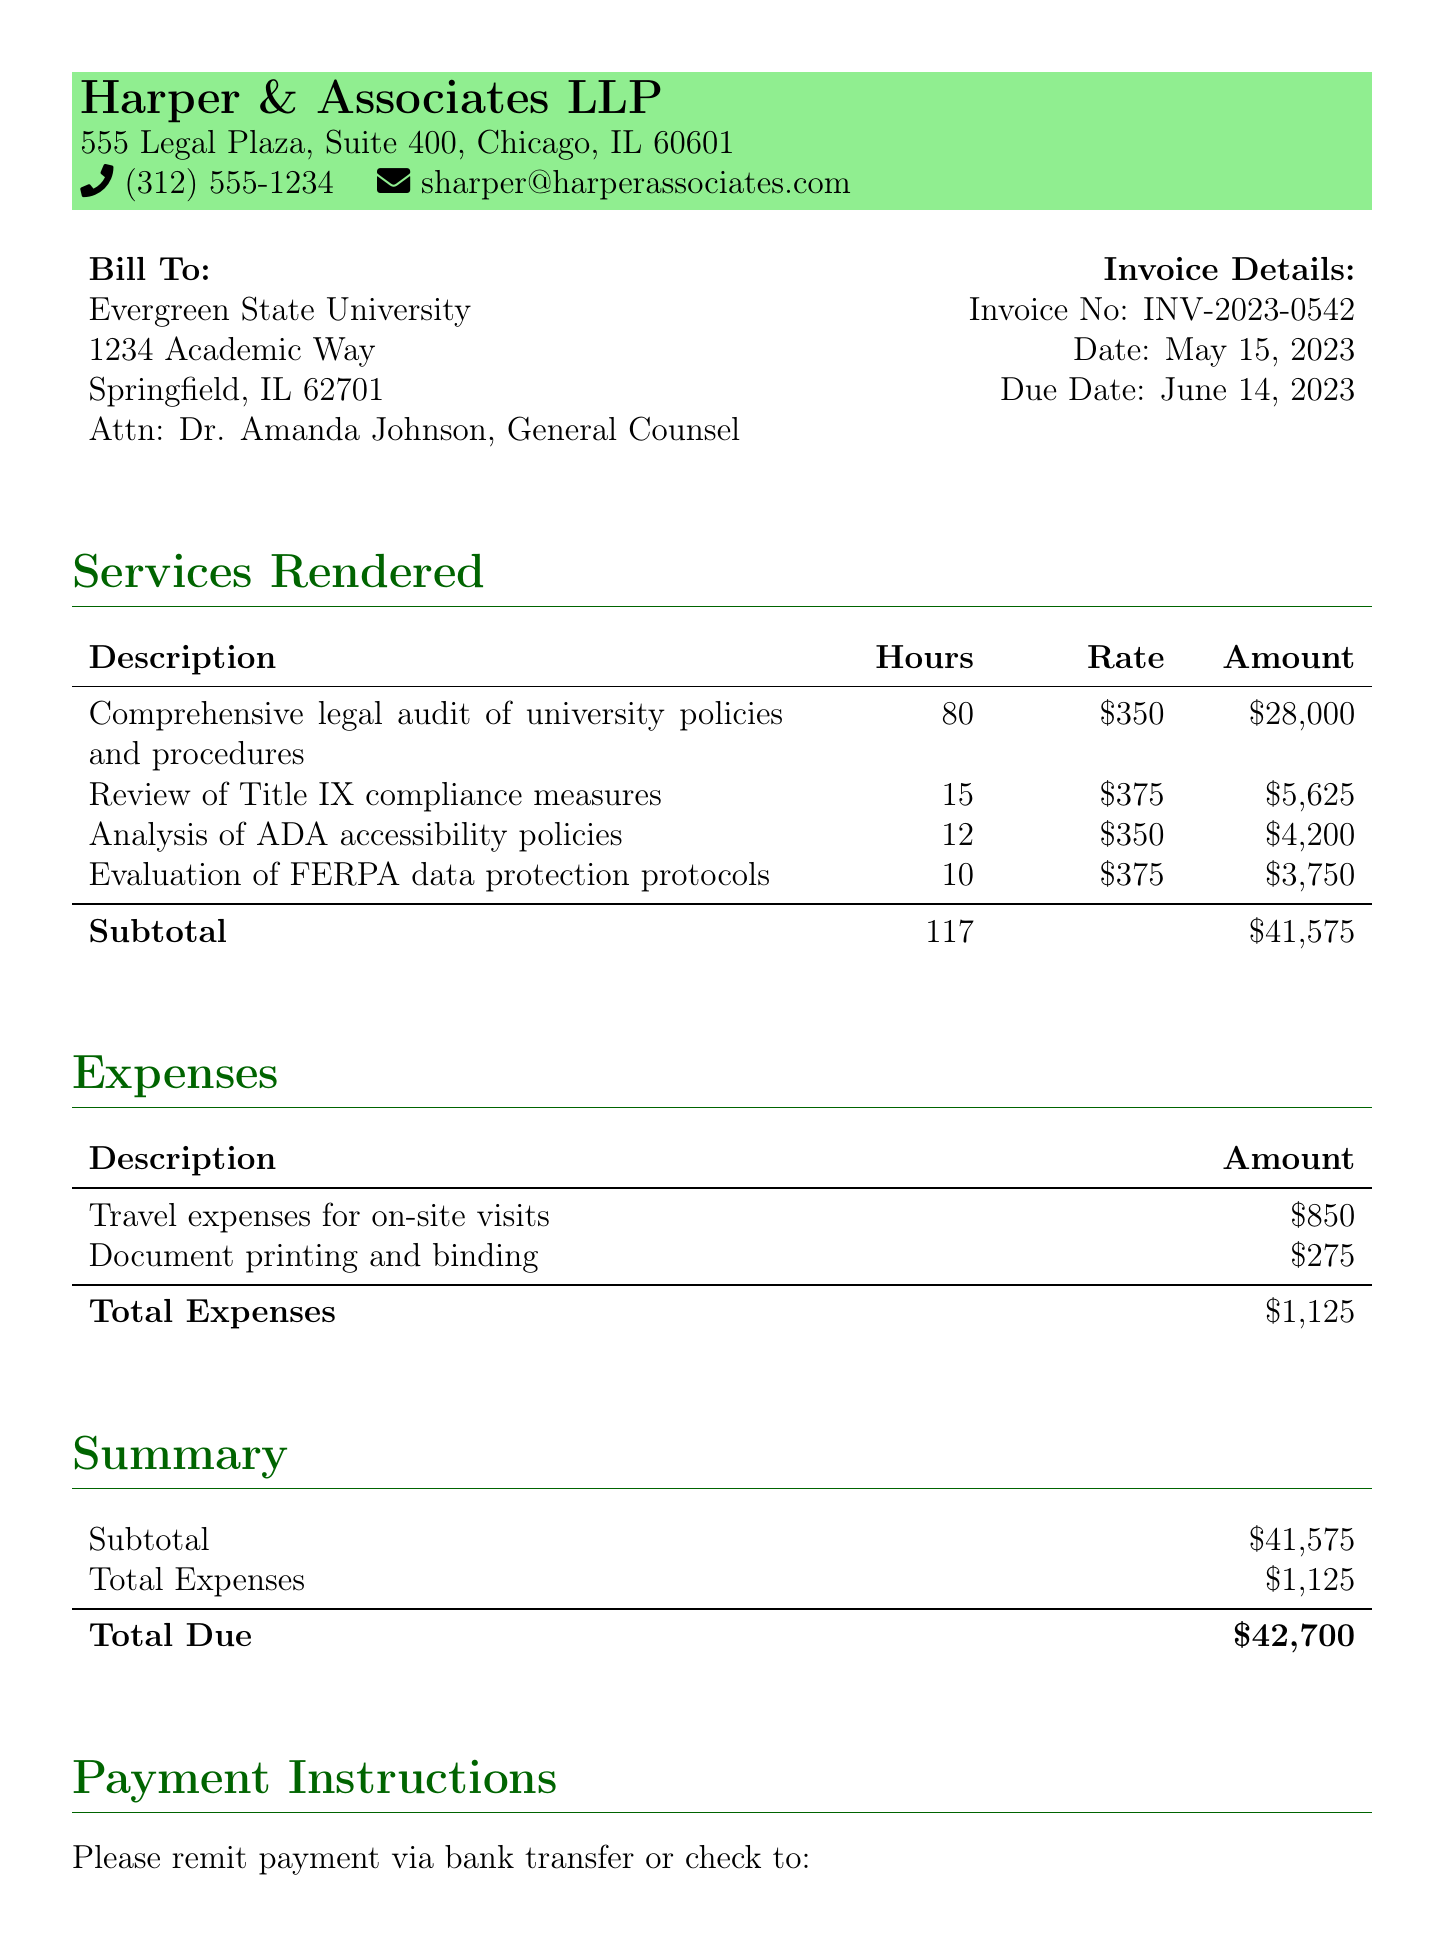What is the invoice number? The invoice number is a unique identifier for the billing statement. It is listed clearly under Invoice Details.
Answer: INV-2023-0542 What is the total amount due? The total amount due is calculated from the subtotal and expenses. It is indicated in the Summary section of the document.
Answer: $42,700 What services were rendered for the legal audit? Services are detailed in the Services Rendered section, outlining various audits and compliance reviews conducted.
Answer: Comprehensive legal audit of university policies and procedures Who is the point of contact at the university? The point of contact is specified in the Bill To section, highlighting the responsible individual for communications.
Answer: Dr. Amanda Johnson, General Counsel How many hours were spent on Title IX compliance measures? The number of hours dedicated to Title IX compliance is noted in the Services Rendered section, which provides detailed accounting of work done.
Answer: 15 What is the rate for evaluating FERPA data protection protocols? The rate is specified in the Services Rendered section where each service includes its corresponding hourly rate.
Answer: $375 What date is the invoice due? The due date for the payment of this invoice is specifically provided in the Invoice Details section.
Answer: June 14, 2023 What are the total expenses incurred? Total expenses consist of various additional costs incurred during the service provision, which are detailed in the Expenses section.
Answer: $1,125 What bank is associated with the payment instructions? The bank for the account where payment should be remitted is specified in the Payment Instructions section of the document.
Answer: Chase Bank 